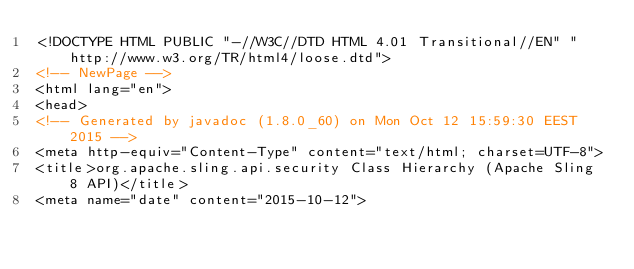Convert code to text. <code><loc_0><loc_0><loc_500><loc_500><_HTML_><!DOCTYPE HTML PUBLIC "-//W3C//DTD HTML 4.01 Transitional//EN" "http://www.w3.org/TR/html4/loose.dtd">
<!-- NewPage -->
<html lang="en">
<head>
<!-- Generated by javadoc (1.8.0_60) on Mon Oct 12 15:59:30 EEST 2015 -->
<meta http-equiv="Content-Type" content="text/html; charset=UTF-8">
<title>org.apache.sling.api.security Class Hierarchy (Apache Sling 8 API)</title>
<meta name="date" content="2015-10-12"></code> 